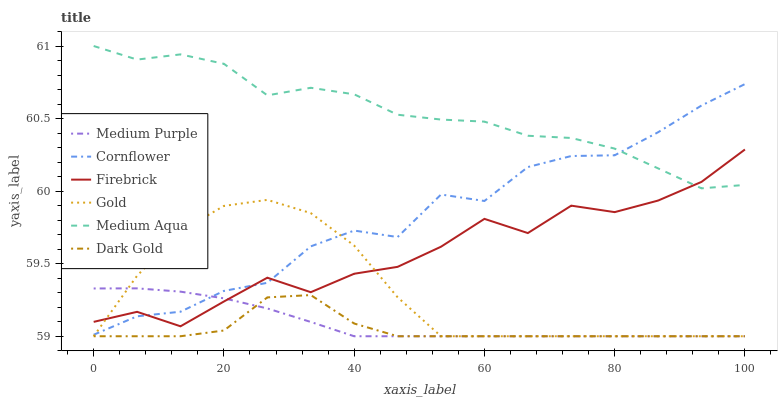Does Gold have the minimum area under the curve?
Answer yes or no. No. Does Gold have the maximum area under the curve?
Answer yes or no. No. Is Gold the smoothest?
Answer yes or no. No. Is Gold the roughest?
Answer yes or no. No. Does Firebrick have the lowest value?
Answer yes or no. No. Does Gold have the highest value?
Answer yes or no. No. Is Gold less than Medium Aqua?
Answer yes or no. Yes. Is Cornflower greater than Dark Gold?
Answer yes or no. Yes. Does Gold intersect Medium Aqua?
Answer yes or no. No. 